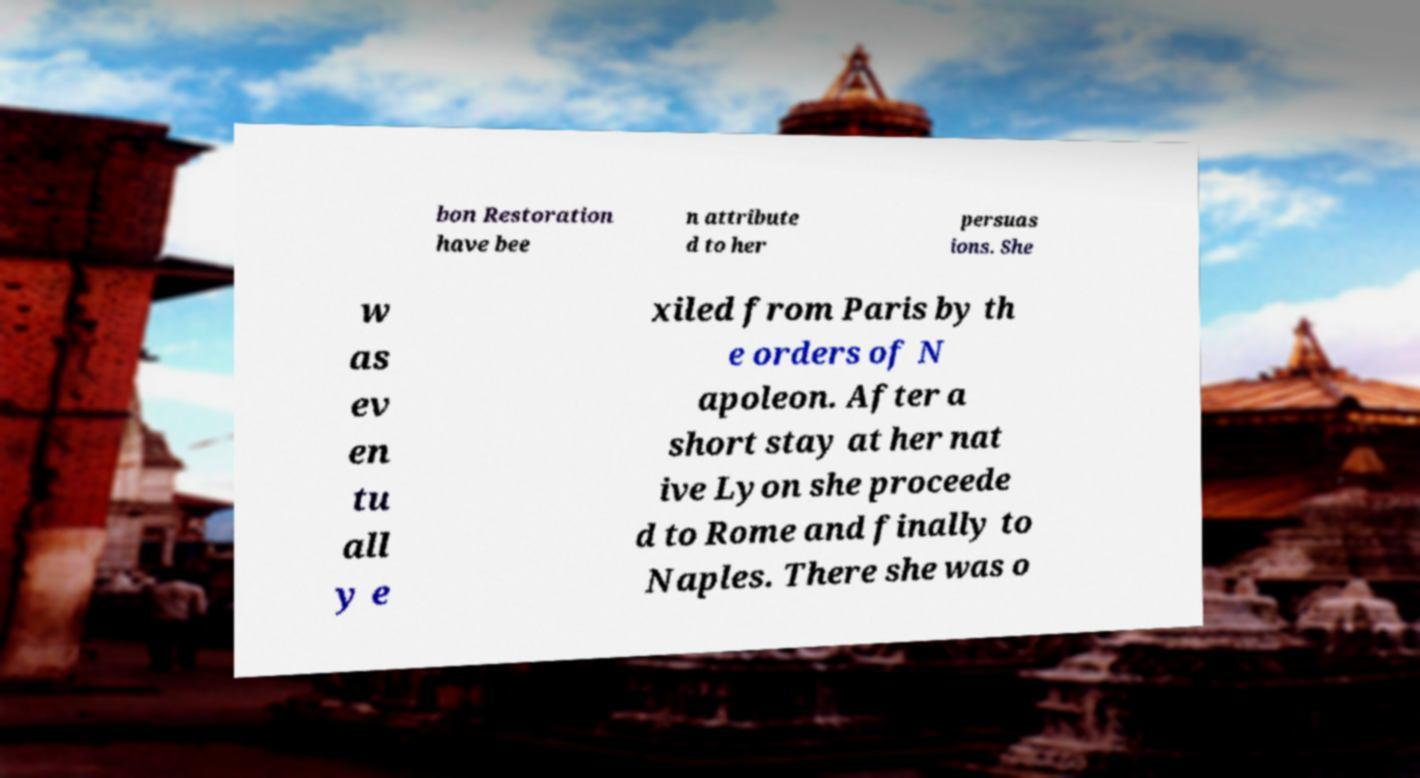Please identify and transcribe the text found in this image. bon Restoration have bee n attribute d to her persuas ions. She w as ev en tu all y e xiled from Paris by th e orders of N apoleon. After a short stay at her nat ive Lyon she proceede d to Rome and finally to Naples. There she was o 